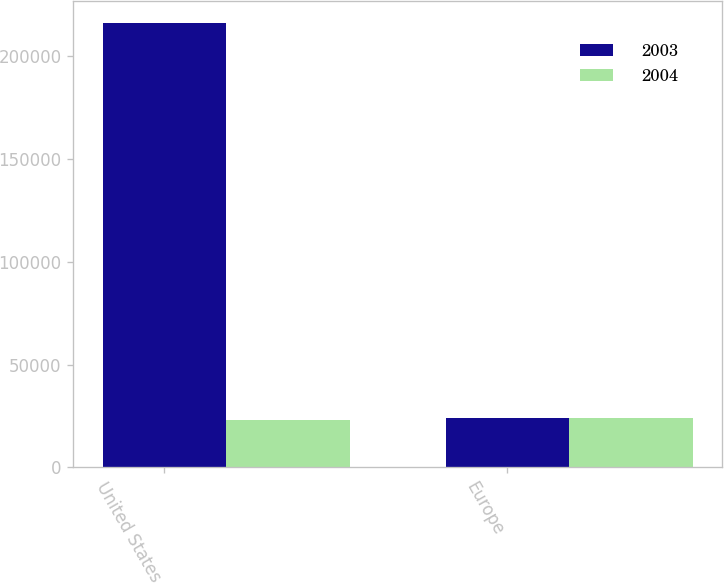Convert chart to OTSL. <chart><loc_0><loc_0><loc_500><loc_500><stacked_bar_chart><ecel><fcel>United States<fcel>Europe<nl><fcel>2003<fcel>216138<fcel>23986<nl><fcel>2004<fcel>22929<fcel>24235<nl></chart> 